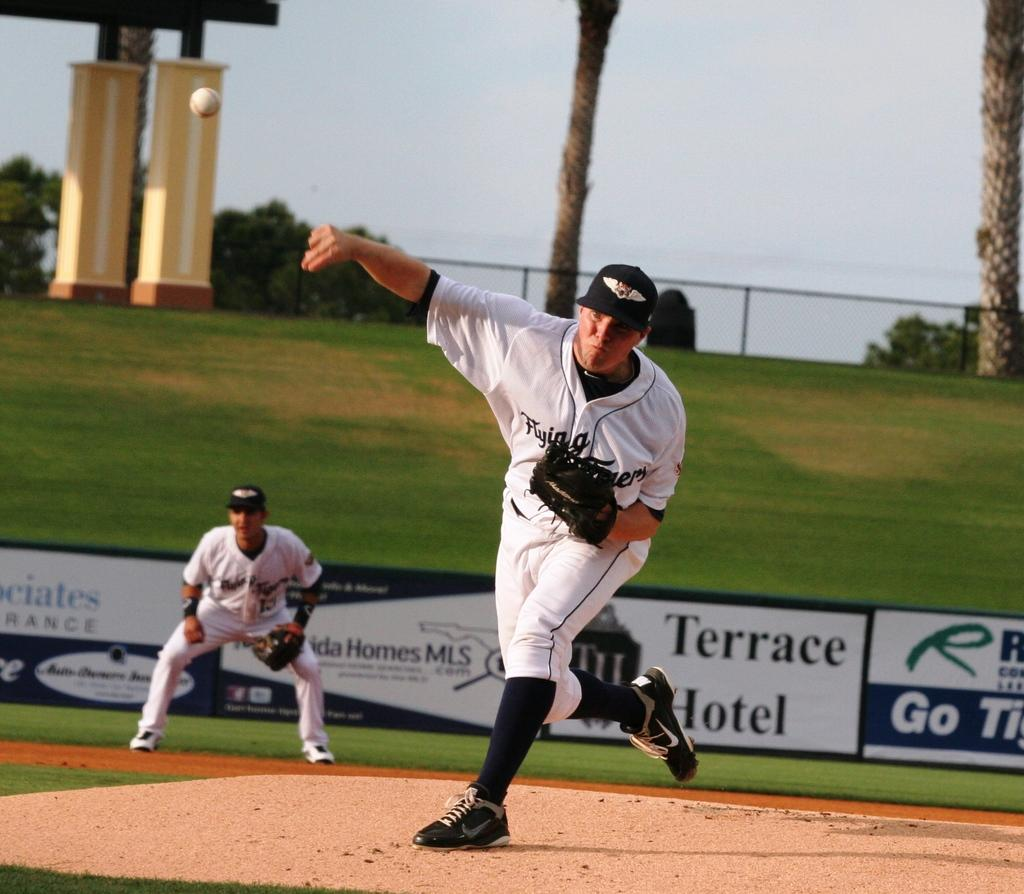<image>
Present a compact description of the photo's key features. a pitcher throwing a ball with Terrace Hotel in the background 